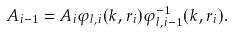Convert formula to latex. <formula><loc_0><loc_0><loc_500><loc_500>A _ { i - 1 } = A _ { i } \varphi _ { l , i } ( k , r _ { i } ) \varphi _ { l , i - 1 } ^ { - 1 } ( k , r _ { i } ) .</formula> 